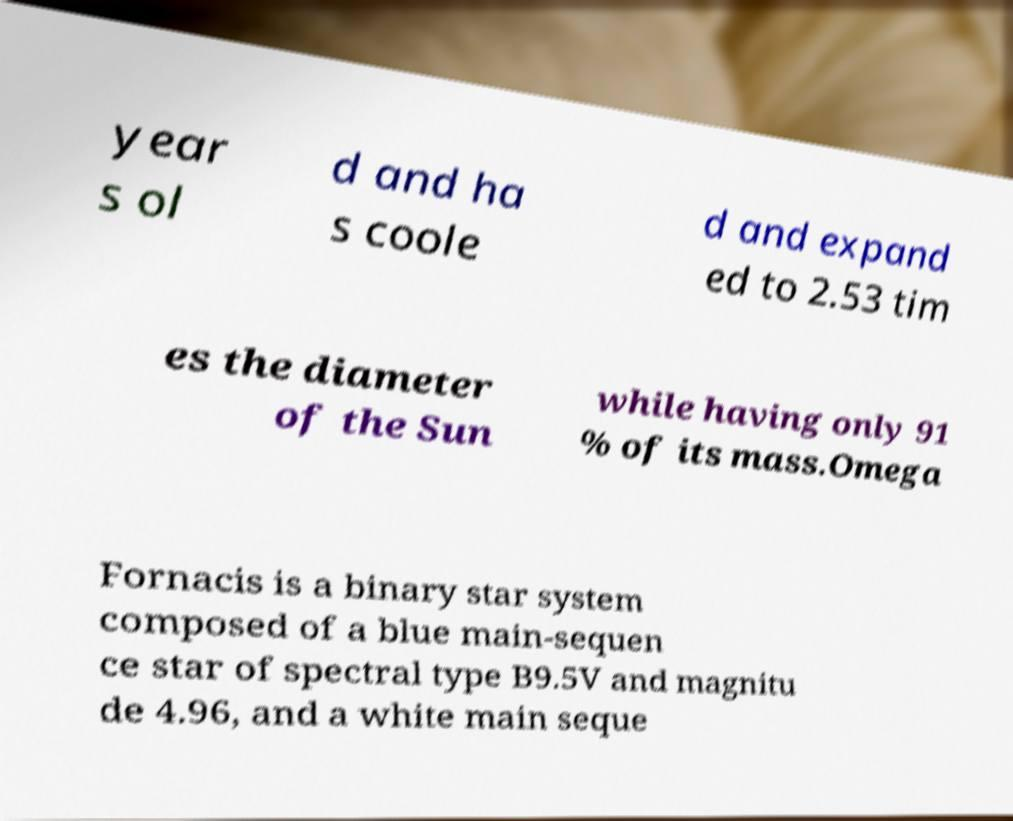Please identify and transcribe the text found in this image. year s ol d and ha s coole d and expand ed to 2.53 tim es the diameter of the Sun while having only 91 % of its mass.Omega Fornacis is a binary star system composed of a blue main-sequen ce star of spectral type B9.5V and magnitu de 4.96, and a white main seque 